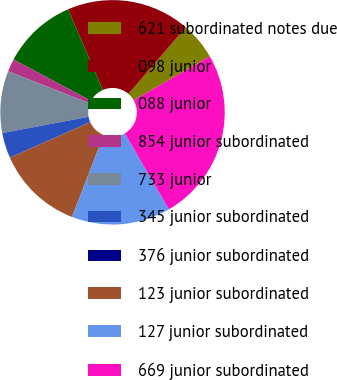Convert chart. <chart><loc_0><loc_0><loc_500><loc_500><pie_chart><fcel>621 subordinated notes due<fcel>098 junior<fcel>088 junior<fcel>854 junior subordinated<fcel>733 junior<fcel>345 junior subordinated<fcel>376 junior subordinated<fcel>123 junior subordinated<fcel>127 junior subordinated<fcel>669 junior subordinated<nl><fcel>5.38%<fcel>17.81%<fcel>10.71%<fcel>1.83%<fcel>8.93%<fcel>3.61%<fcel>0.06%<fcel>12.49%<fcel>14.26%<fcel>24.92%<nl></chart> 